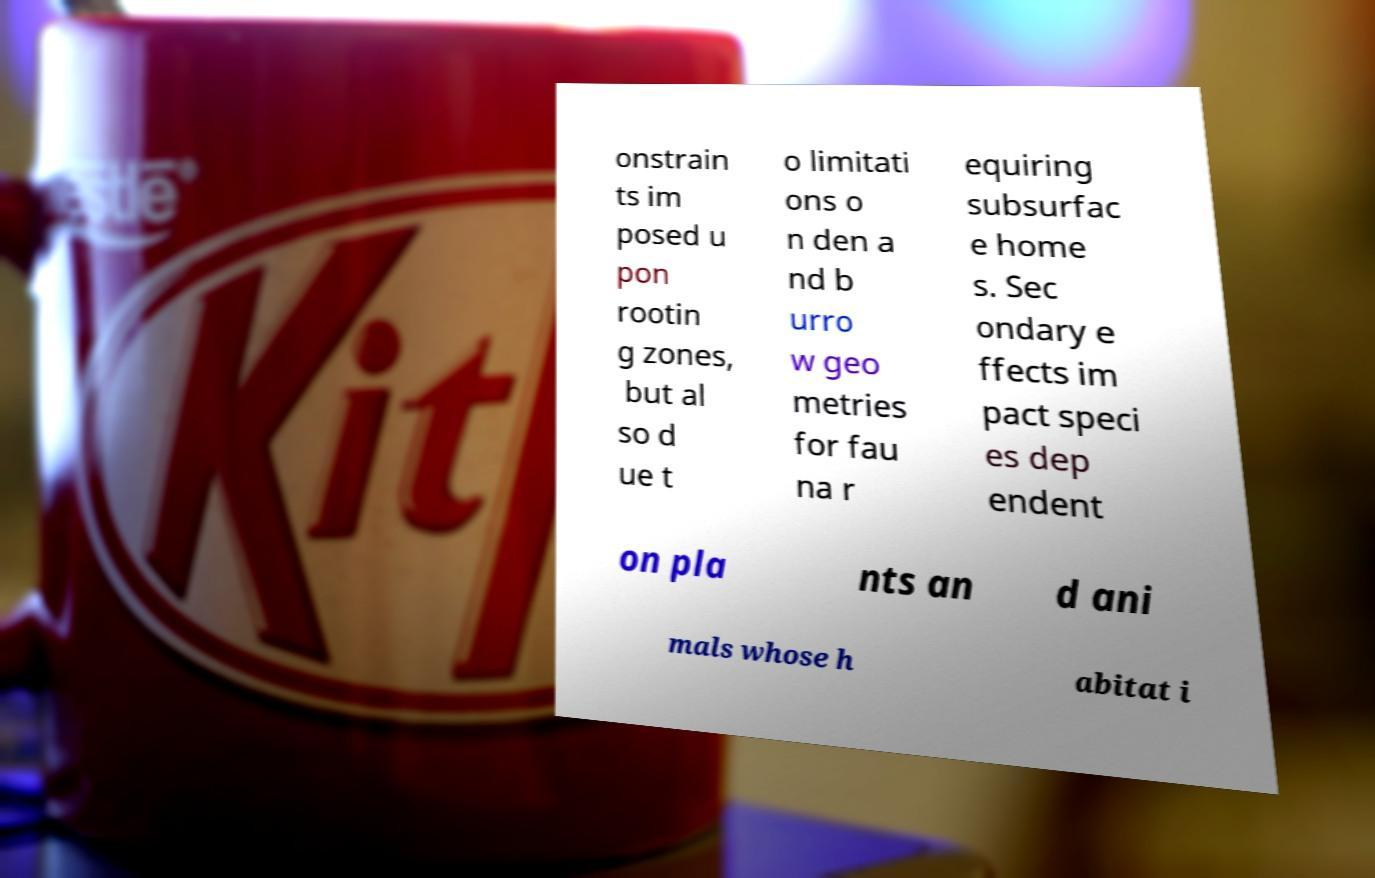I need the written content from this picture converted into text. Can you do that? onstrain ts im posed u pon rootin g zones, but al so d ue t o limitati ons o n den a nd b urro w geo metries for fau na r equiring subsurfac e home s. Sec ondary e ffects im pact speci es dep endent on pla nts an d ani mals whose h abitat i 